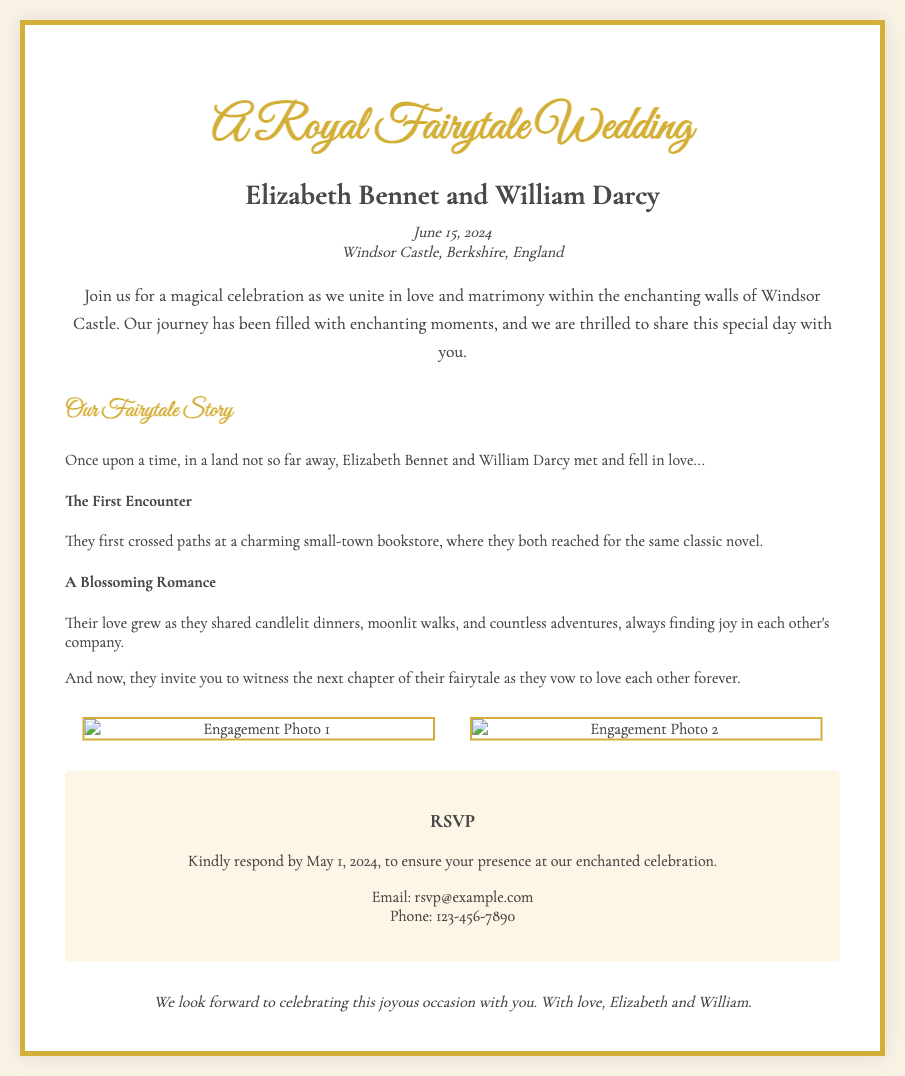What is the couple's name? The couple's name is mentioned at the top of the invitation, specifically highlighted in the names section.
Answer: Elizabeth Bennet and William Darcy What is the wedding date? The date of the wedding is clearly stated in the invitation underneath the name section.
Answer: June 15, 2024 Where is the wedding venue? The venue location is provided right under the wedding date, indicating the specific place of the event.
Answer: Windsor Castle, Berkshire, England What should guests do by May 1, 2024? The invitation explicitly requests a certain action to be completed by this date for guests.
Answer: RSVP What theme is the wedding? The overall theme of the wedding is expressed through the invitation's title and design elements.
Answer: Fairytale What type of photos are included in the invitation? The invitation mentions the kind of images that showcase moments from the couple’s journey together.
Answer: Engagement photos What literary element is featured in the invitation? The invitation includes a narrative section that tells about the couple's journey as if it were a story.
Answer: Storybook What color is the border of the invitation? The specific color of the border is specified in the design description of the invitation.
Answer: Gold What type of design is used in the invitation? The overall style of the invitation is described in the introduction.
Answer: Royal and enchanting design 